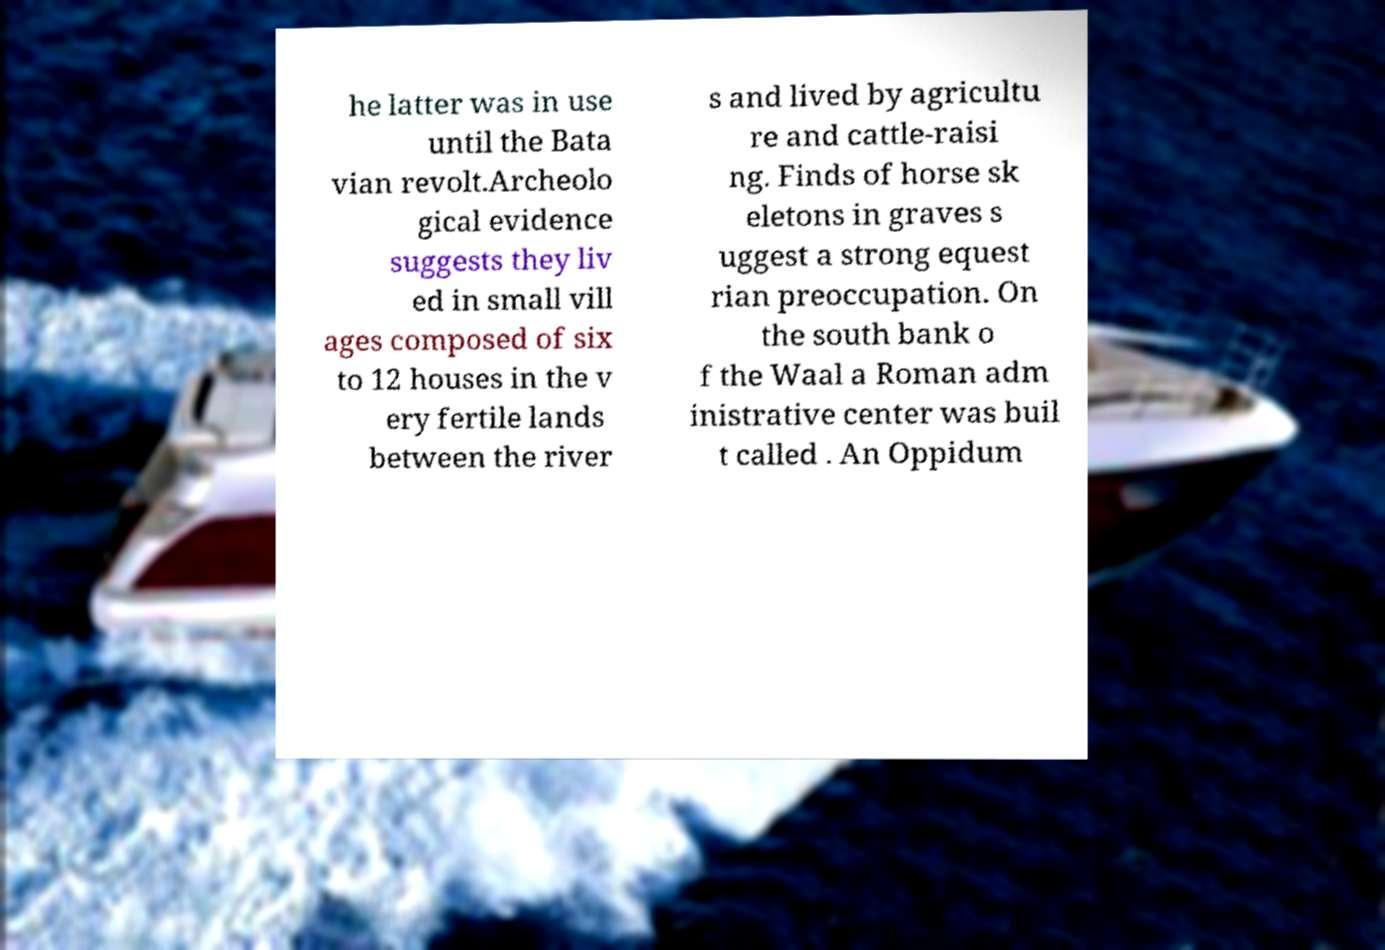There's text embedded in this image that I need extracted. Can you transcribe it verbatim? he latter was in use until the Bata vian revolt.Archeolo gical evidence suggests they liv ed in small vill ages composed of six to 12 houses in the v ery fertile lands between the river s and lived by agricultu re and cattle-raisi ng. Finds of horse sk eletons in graves s uggest a strong equest rian preoccupation. On the south bank o f the Waal a Roman adm inistrative center was buil t called . An Oppidum 